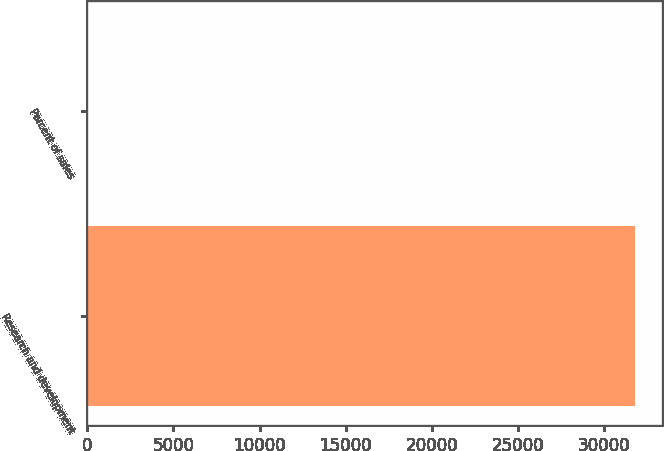<chart> <loc_0><loc_0><loc_500><loc_500><bar_chart><fcel>Research and development<fcel>Percent of sales<nl><fcel>31759<fcel>5.9<nl></chart> 